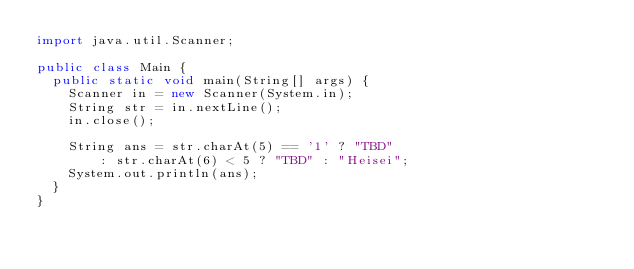<code> <loc_0><loc_0><loc_500><loc_500><_Java_>import java.util.Scanner;

public class Main {
	public static void main(String[] args) {
		Scanner in = new Scanner(System.in);
		String str = in.nextLine();
		in.close();
		
		String ans = str.charAt(5) == '1' ? "TBD"
				: str.charAt(6) < 5 ? "TBD" : "Heisei";
		System.out.println(ans);
	}
}
</code> 